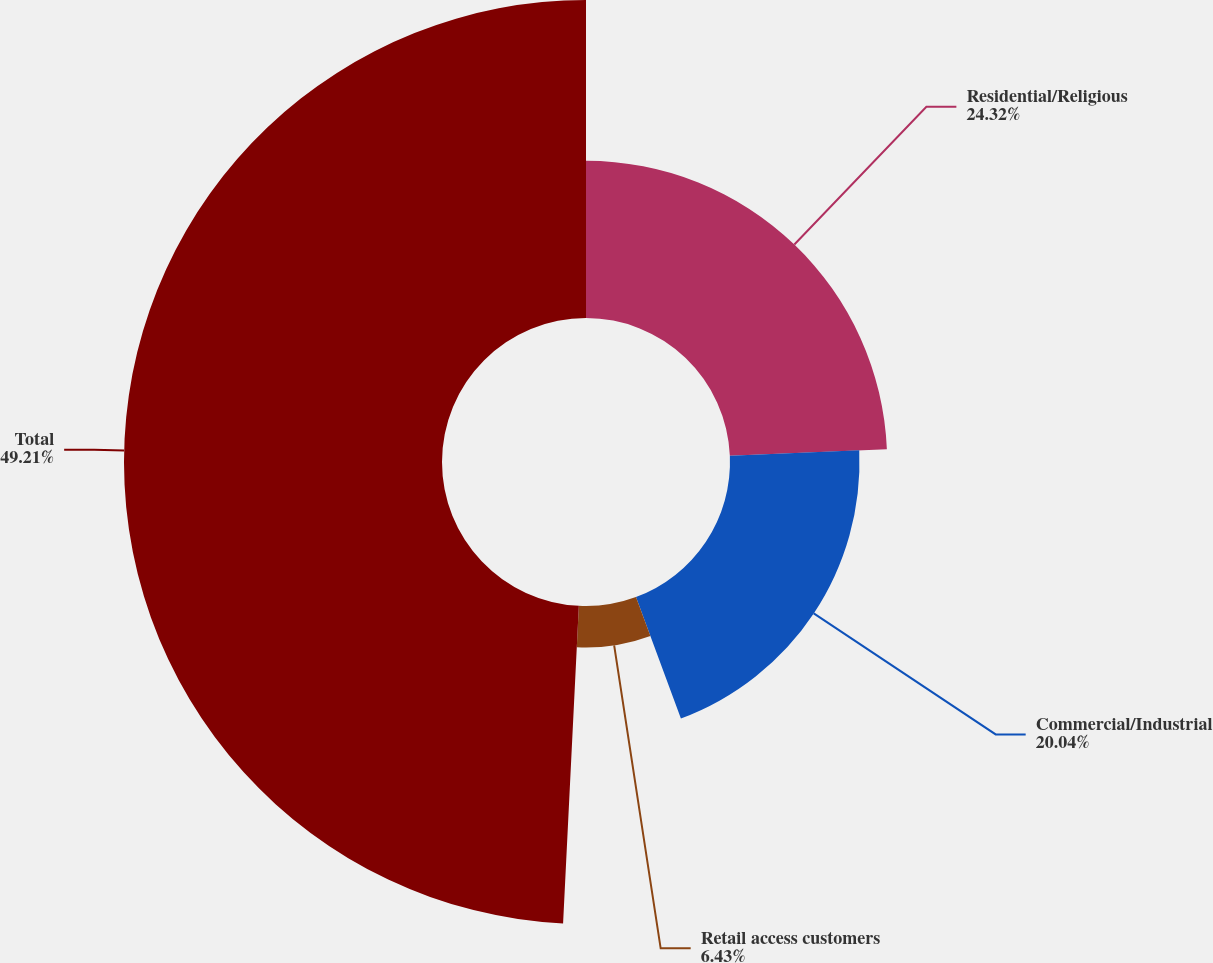<chart> <loc_0><loc_0><loc_500><loc_500><pie_chart><fcel>Residential/Religious<fcel>Commercial/Industrial<fcel>Retail access customers<fcel>Total<nl><fcel>24.32%<fcel>20.04%<fcel>6.43%<fcel>49.21%<nl></chart> 